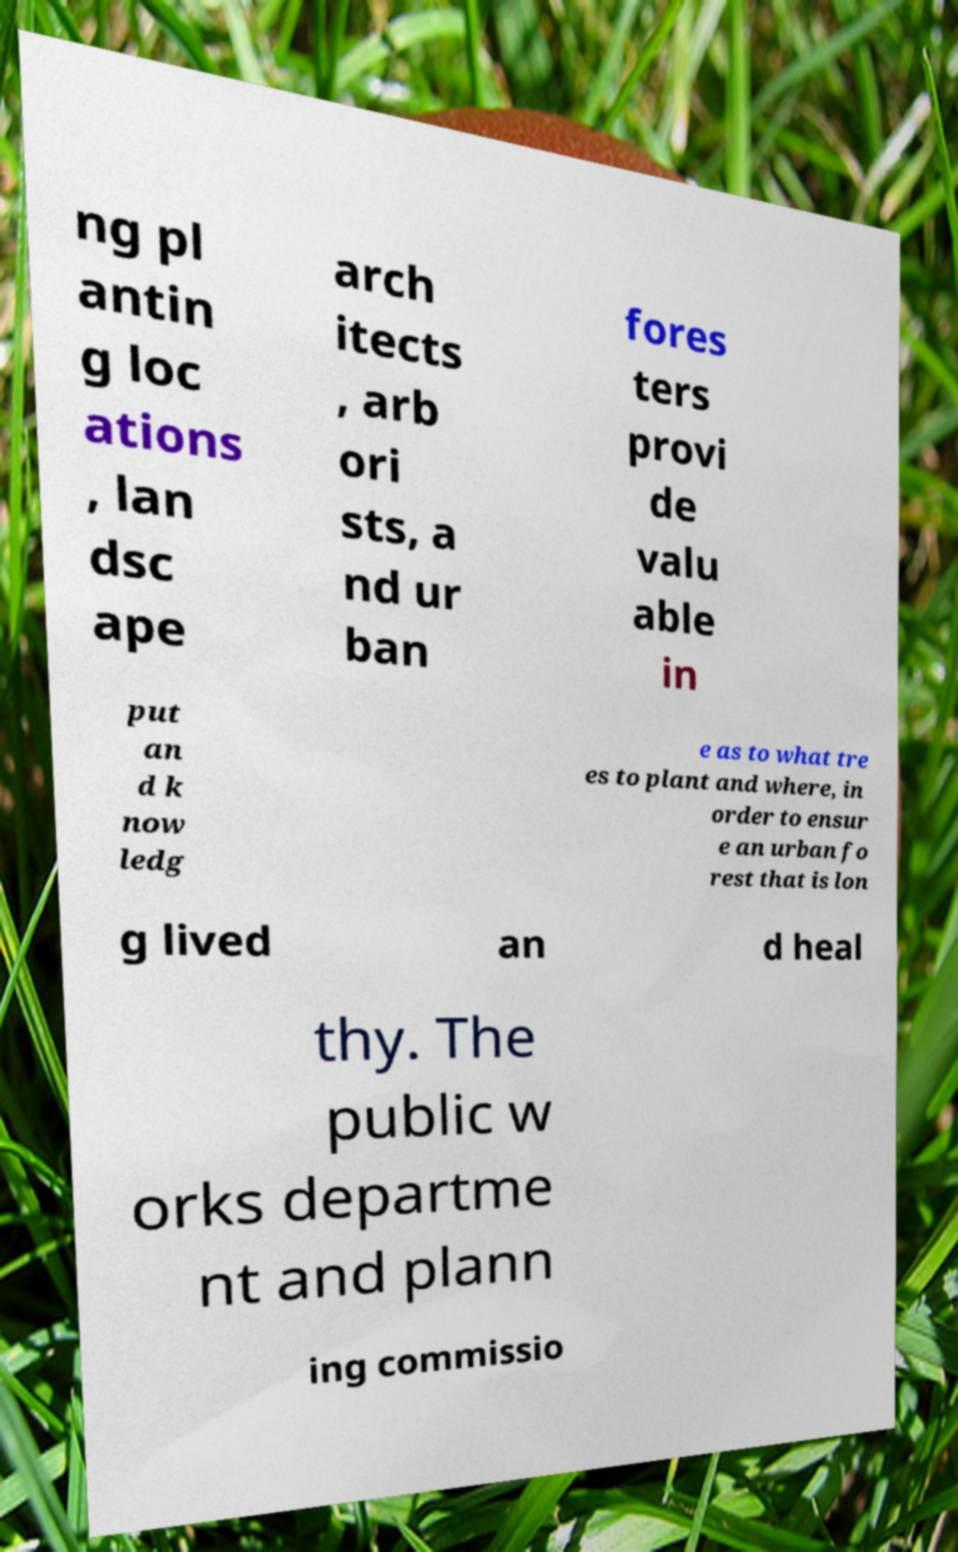There's text embedded in this image that I need extracted. Can you transcribe it verbatim? ng pl antin g loc ations , lan dsc ape arch itects , arb ori sts, a nd ur ban fores ters provi de valu able in put an d k now ledg e as to what tre es to plant and where, in order to ensur e an urban fo rest that is lon g lived an d heal thy. The public w orks departme nt and plann ing commissio 